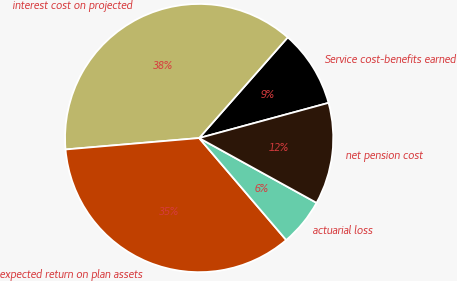Convert chart. <chart><loc_0><loc_0><loc_500><loc_500><pie_chart><fcel>Service cost-benefits earned<fcel>interest cost on projected<fcel>expected return on plan assets<fcel>actuarial loss<fcel>net pension cost<nl><fcel>9.29%<fcel>37.84%<fcel>34.89%<fcel>5.73%<fcel>12.25%<nl></chart> 